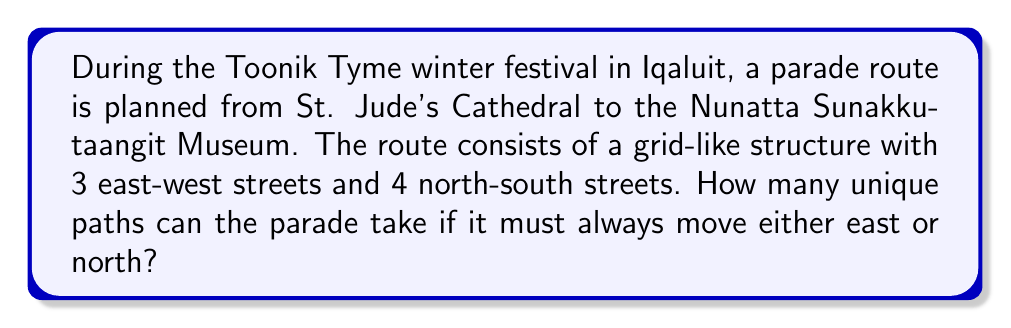Solve this math problem. Let's approach this step-by-step:

1) First, we need to understand what the question is asking. We're looking for the number of unique paths from one corner of a grid to the opposite corner, moving only east or north.

2) This is a classic combination problem. The key insight is that regardless of the path taken, the parade will always move 2 blocks east and 3 blocks north to reach its destination.

3) Therefore, we need to calculate how many ways we can arrange 2 east moves and 3 north moves.

4) This is equivalent to asking: "In how many ways can we arrange 5 items, where 2 are identical (east moves) and 3 are identical (north moves)?"

5) This is a combination with repetition problem. The formula for this is:

   $$\frac{(n_1 + n_2)!}{n_1! \cdot n_2!}$$

   Where $n_1$ is the number of east moves and $n_2$ is the number of north moves.

6) Plugging in our values:

   $$\frac{(2 + 3)!}{2! \cdot 3!} = \frac{5!}{2! \cdot 3!}$$

7) Let's calculate this:
   
   $$\frac{5 \cdot 4 \cdot 3!}{2 \cdot 1 \cdot 3!} = \frac{20}{2} = 10$$

Thus, there are 10 unique paths the parade can take.
Answer: 10 unique paths 